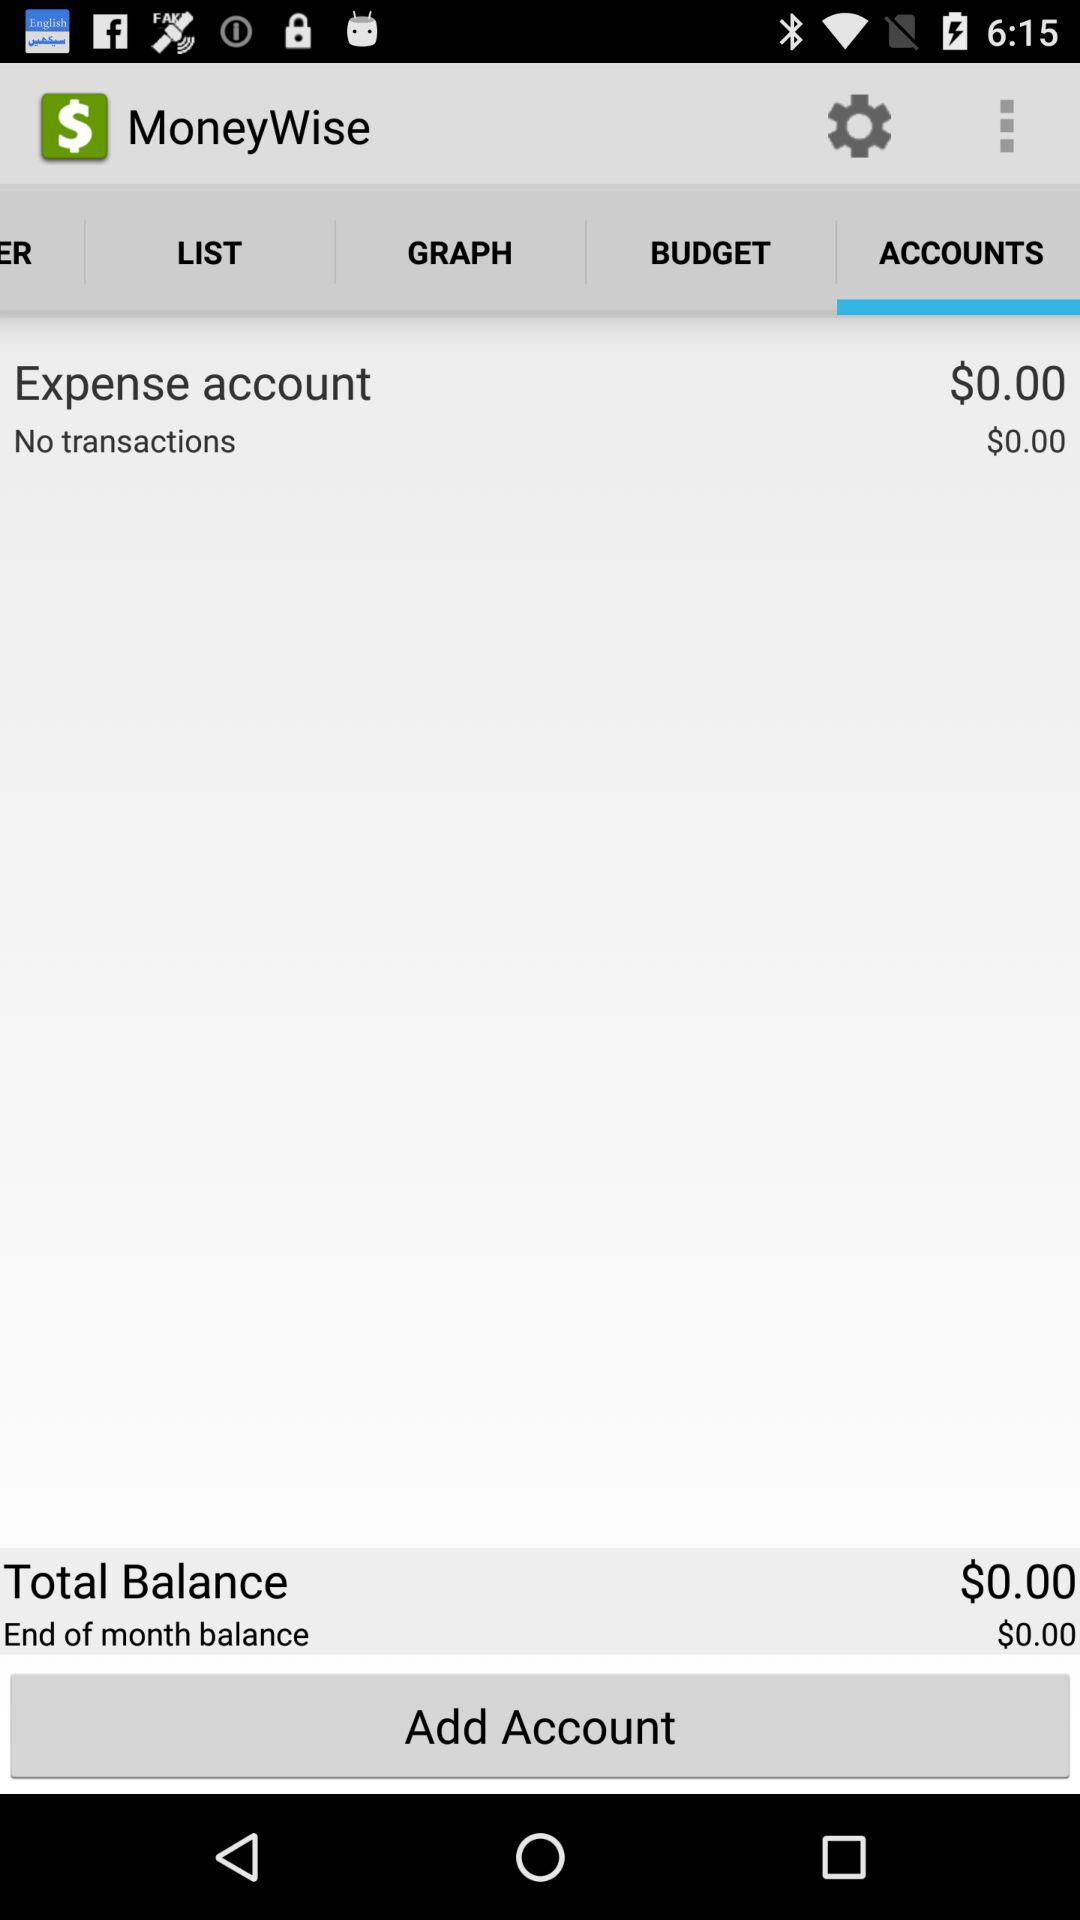How many transactions are there?
Answer the question using a single word or phrase. 0 